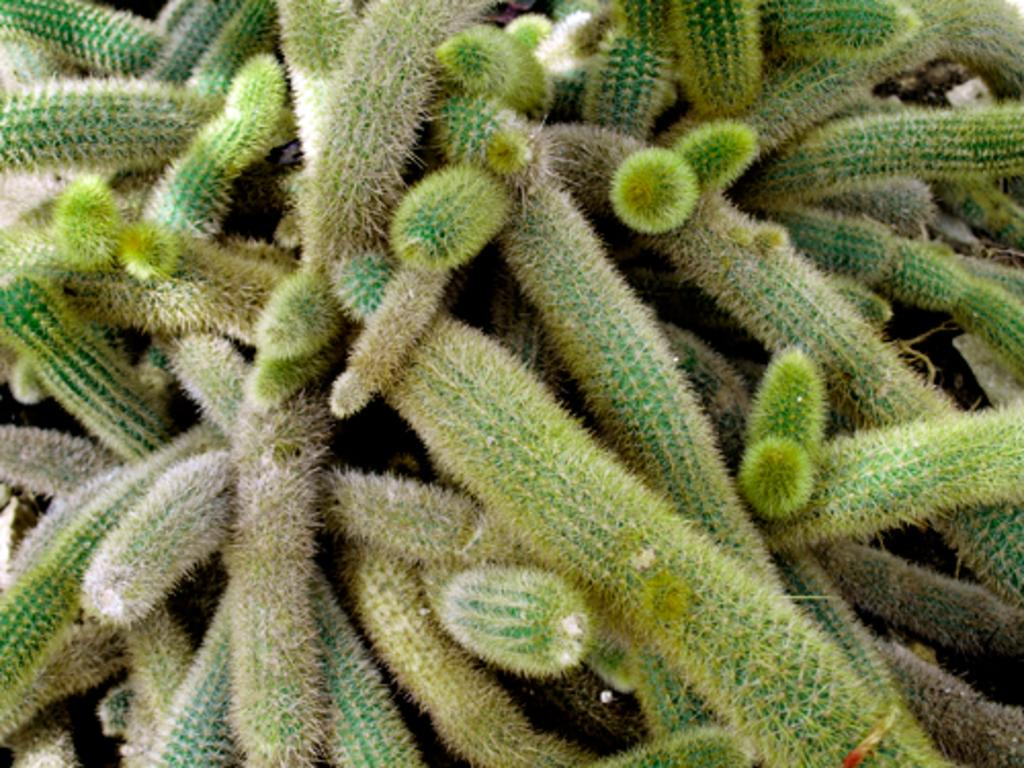What type of living organism can be seen in the image? There is a plant in the image. What type of sheet is covering the plant in the image? There is no sheet covering the plant in the plant in the image; it is not mentioned in the provided facts. 